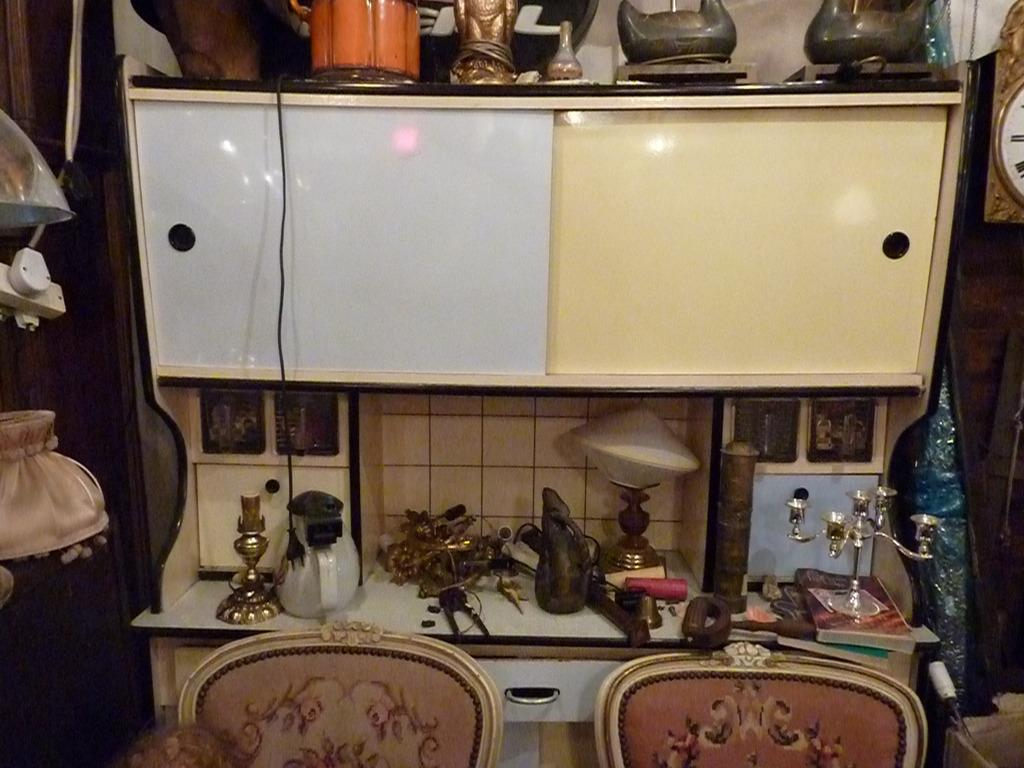What type of furniture is present in the image? There is a cabinet in the image. What can be seen on top of the cabinet? There are different objects on the cabinet. Where is the switchboard located in the image? There is a plug in the switchboard on the left side of the image. What time-keeping device is on the right side of the image? There is a clock on the right side of the image. What type of humor can be seen in the image? There is no humor present in the image; it is a picture of a cabinet with objects on top, a switchboard, and a clock. Is there a hat visible in the image? There is no hat present in the image. 